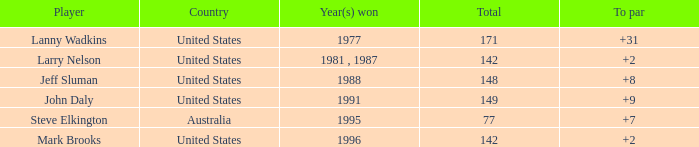Name the To par that has a Year(s) won of 1988 and a Total smaller than 148? None. 